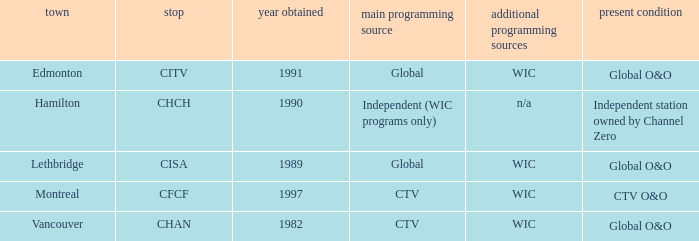Where is citv located Edmonton. Could you parse the entire table as a dict? {'header': ['town', 'stop', 'year obtained', 'main programming source', 'additional programming sources', 'present condition'], 'rows': [['Edmonton', 'CITV', '1991', 'Global', 'WIC', 'Global O&O'], ['Hamilton', 'CHCH', '1990', 'Independent (WIC programs only)', 'n/a', 'Independent station owned by Channel Zero'], ['Lethbridge', 'CISA', '1989', 'Global', 'WIC', 'Global O&O'], ['Montreal', 'CFCF', '1997', 'CTV', 'WIC', 'CTV O&O'], ['Vancouver', 'CHAN', '1982', 'CTV', 'WIC', 'Global O&O']]} 